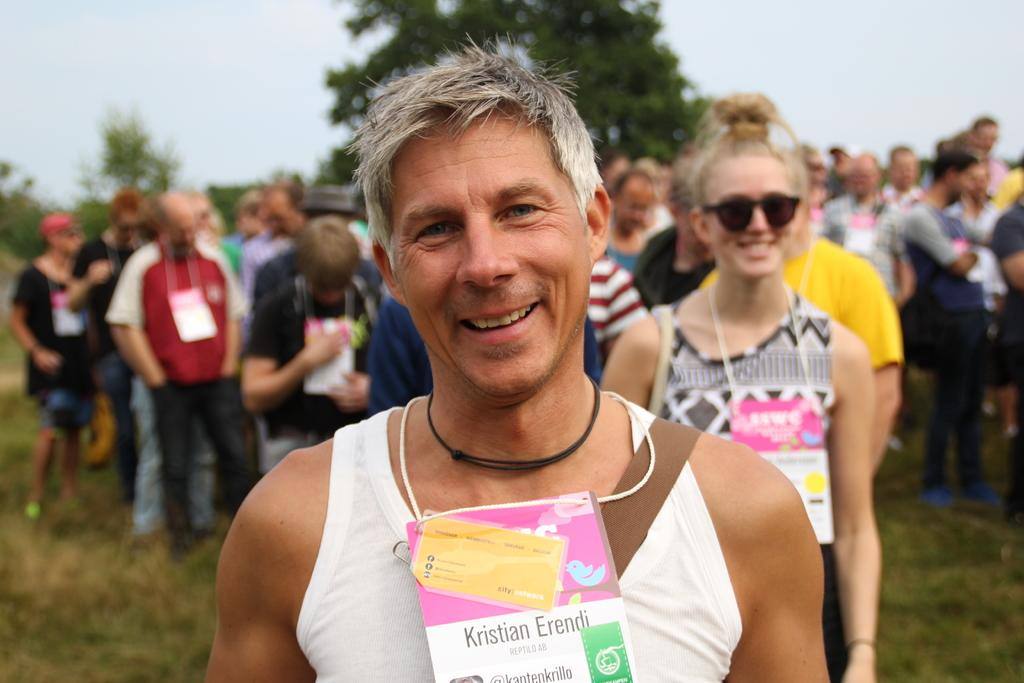What is present in the image? There is a person in the image. Can you describe the person in the image? The person has a tag. What can be seen in the background of the image? There are people, trees, grass, and the sky visible in the background of the image. What type of news is the secretary delivering in the image? There is no secretary or news present in the image; it only features a person with a tag and the background elements. 